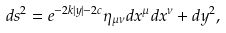<formula> <loc_0><loc_0><loc_500><loc_500>d s ^ { 2 } = e ^ { - 2 k | y | - 2 c } \eta _ { \mu \nu } d x ^ { \mu } d x ^ { \nu } + d y ^ { 2 } ,</formula> 